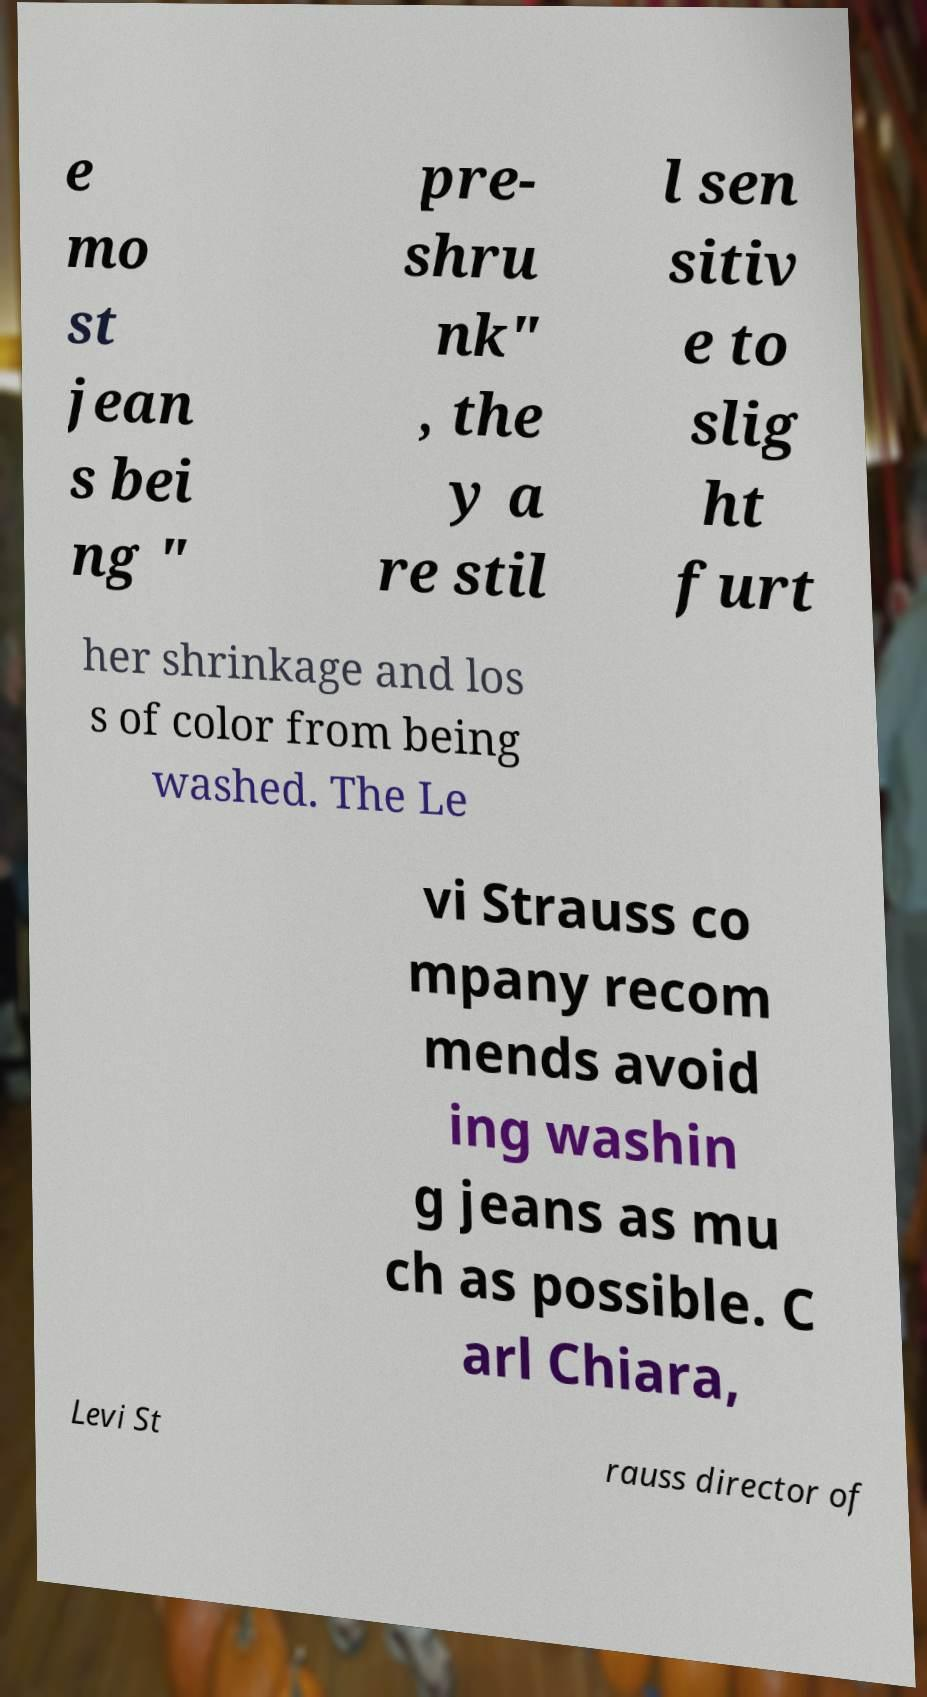What messages or text are displayed in this image? I need them in a readable, typed format. e mo st jean s bei ng " pre- shru nk" , the y a re stil l sen sitiv e to slig ht furt her shrinkage and los s of color from being washed. The Le vi Strauss co mpany recom mends avoid ing washin g jeans as mu ch as possible. C arl Chiara, Levi St rauss director of 